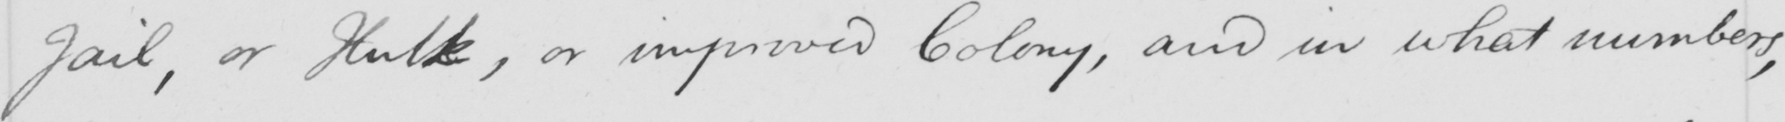Can you tell me what this handwritten text says? Jail, or Hulk, or improved Colony, and in what numbers, 